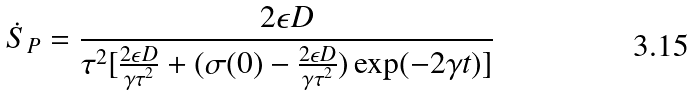<formula> <loc_0><loc_0><loc_500><loc_500>\dot { S } _ { P } = \frac { 2 \epsilon D } { \tau ^ { 2 } [ \frac { 2 \epsilon D } { \gamma \tau ^ { 2 } } + ( \sigma ( 0 ) - \frac { 2 \epsilon D } { \gamma \tau ^ { 2 } } ) \exp ( - 2 \gamma t ) ] }</formula> 